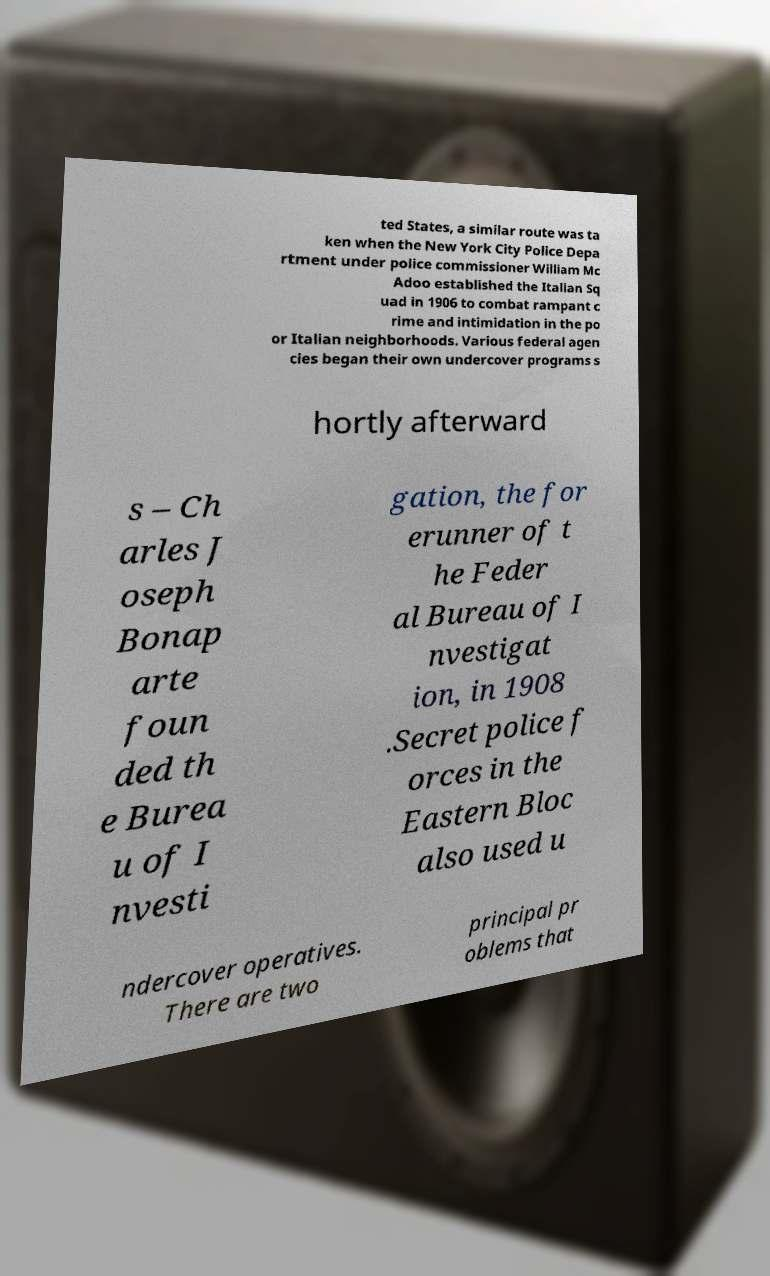I need the written content from this picture converted into text. Can you do that? ted States, a similar route was ta ken when the New York City Police Depa rtment under police commissioner William Mc Adoo established the Italian Sq uad in 1906 to combat rampant c rime and intimidation in the po or Italian neighborhoods. Various federal agen cies began their own undercover programs s hortly afterward s – Ch arles J oseph Bonap arte foun ded th e Burea u of I nvesti gation, the for erunner of t he Feder al Bureau of I nvestigat ion, in 1908 .Secret police f orces in the Eastern Bloc also used u ndercover operatives. There are two principal pr oblems that 